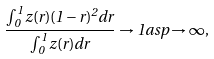<formula> <loc_0><loc_0><loc_500><loc_500>\frac { \int _ { 0 } ^ { 1 } z ( r ) ( 1 - r ) ^ { 2 } d r } { \int _ { 0 } ^ { 1 } z ( r ) d r } \to 1 a s p \to \infty ,</formula> 